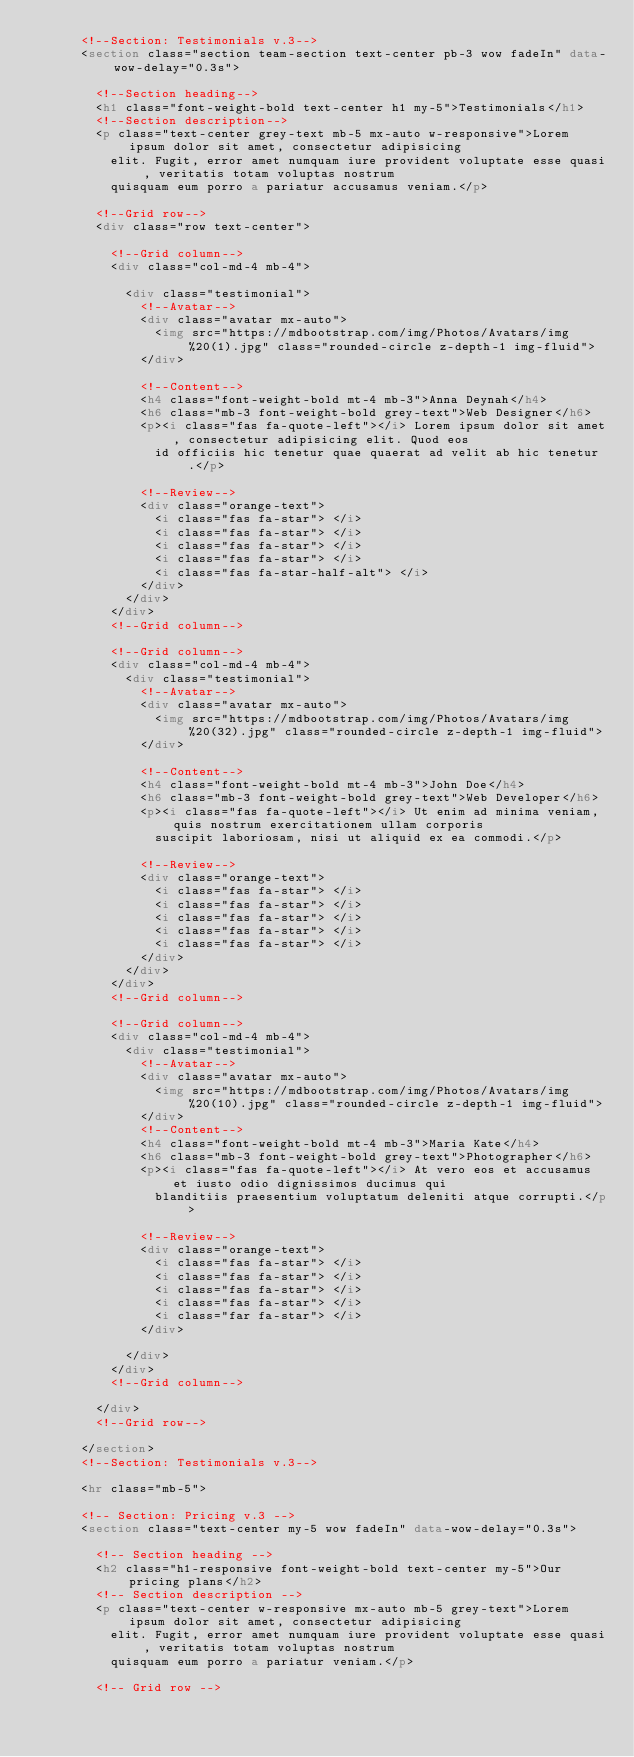<code> <loc_0><loc_0><loc_500><loc_500><_HTML_>      <!--Section: Testimonials v.3-->
      <section class="section team-section text-center pb-3 wow fadeIn" data-wow-delay="0.3s">

        <!--Section heading-->
        <h1 class="font-weight-bold text-center h1 my-5">Testimonials</h1>
        <!--Section description-->
        <p class="text-center grey-text mb-5 mx-auto w-responsive">Lorem ipsum dolor sit amet, consectetur adipisicing
          elit. Fugit, error amet numquam iure provident voluptate esse quasi, veritatis totam voluptas nostrum
          quisquam eum porro a pariatur accusamus veniam.</p>

        <!--Grid row-->
        <div class="row text-center">

          <!--Grid column-->
          <div class="col-md-4 mb-4">

            <div class="testimonial">
              <!--Avatar-->
              <div class="avatar mx-auto">
                <img src="https://mdbootstrap.com/img/Photos/Avatars/img%20(1).jpg" class="rounded-circle z-depth-1 img-fluid">
              </div>

              <!--Content-->
              <h4 class="font-weight-bold mt-4 mb-3">Anna Deynah</h4>
              <h6 class="mb-3 font-weight-bold grey-text">Web Designer</h6>
              <p><i class="fas fa-quote-left"></i> Lorem ipsum dolor sit amet, consectetur adipisicing elit. Quod eos
                id officiis hic tenetur quae quaerat ad velit ab hic tenetur.</p>

              <!--Review-->
              <div class="orange-text">
                <i class="fas fa-star"> </i>
                <i class="fas fa-star"> </i>
                <i class="fas fa-star"> </i>
                <i class="fas fa-star"> </i>
                <i class="fas fa-star-half-alt"> </i>
              </div>
            </div>
          </div>
          <!--Grid column-->

          <!--Grid column-->
          <div class="col-md-4 mb-4">
            <div class="testimonial">
              <!--Avatar-->
              <div class="avatar mx-auto">
                <img src="https://mdbootstrap.com/img/Photos/Avatars/img%20(32).jpg" class="rounded-circle z-depth-1 img-fluid">
              </div>

              <!--Content-->
              <h4 class="font-weight-bold mt-4 mb-3">John Doe</h4>
              <h6 class="mb-3 font-weight-bold grey-text">Web Developer</h6>
              <p><i class="fas fa-quote-left"></i> Ut enim ad minima veniam, quis nostrum exercitationem ullam corporis
                suscipit laboriosam, nisi ut aliquid ex ea commodi.</p>

              <!--Review-->
              <div class="orange-text">
                <i class="fas fa-star"> </i>
                <i class="fas fa-star"> </i>
                <i class="fas fa-star"> </i>
                <i class="fas fa-star"> </i>
                <i class="fas fa-star"> </i>
              </div>
            </div>
          </div>
          <!--Grid column-->

          <!--Grid column-->
          <div class="col-md-4 mb-4">
            <div class="testimonial">
              <!--Avatar-->
              <div class="avatar mx-auto">
                <img src="https://mdbootstrap.com/img/Photos/Avatars/img%20(10).jpg" class="rounded-circle z-depth-1 img-fluid">
              </div>
              <!--Content-->
              <h4 class="font-weight-bold mt-4 mb-3">Maria Kate</h4>
              <h6 class="mb-3 font-weight-bold grey-text">Photographer</h6>
              <p><i class="fas fa-quote-left"></i> At vero eos et accusamus et iusto odio dignissimos ducimus qui
                blanditiis praesentium voluptatum deleniti atque corrupti.</p>

              <!--Review-->
              <div class="orange-text">
                <i class="fas fa-star"> </i>
                <i class="fas fa-star"> </i>
                <i class="fas fa-star"> </i>
                <i class="fas fa-star"> </i>
                <i class="far fa-star"> </i>
              </div>

            </div>
          </div>
          <!--Grid column-->

        </div>
        <!--Grid row-->

      </section>
      <!--Section: Testimonials v.3-->

      <hr class="mb-5">

      <!-- Section: Pricing v.3 -->
      <section class="text-center my-5 wow fadeIn" data-wow-delay="0.3s">

        <!-- Section heading -->
        <h2 class="h1-responsive font-weight-bold text-center my-5">Our pricing plans</h2>
        <!-- Section description -->
        <p class="text-center w-responsive mx-auto mb-5 grey-text">Lorem ipsum dolor sit amet, consectetur adipisicing
          elit. Fugit, error amet numquam iure provident voluptate esse quasi, veritatis totam voluptas nostrum
          quisquam eum porro a pariatur veniam.</p>

        <!-- Grid row --></code> 